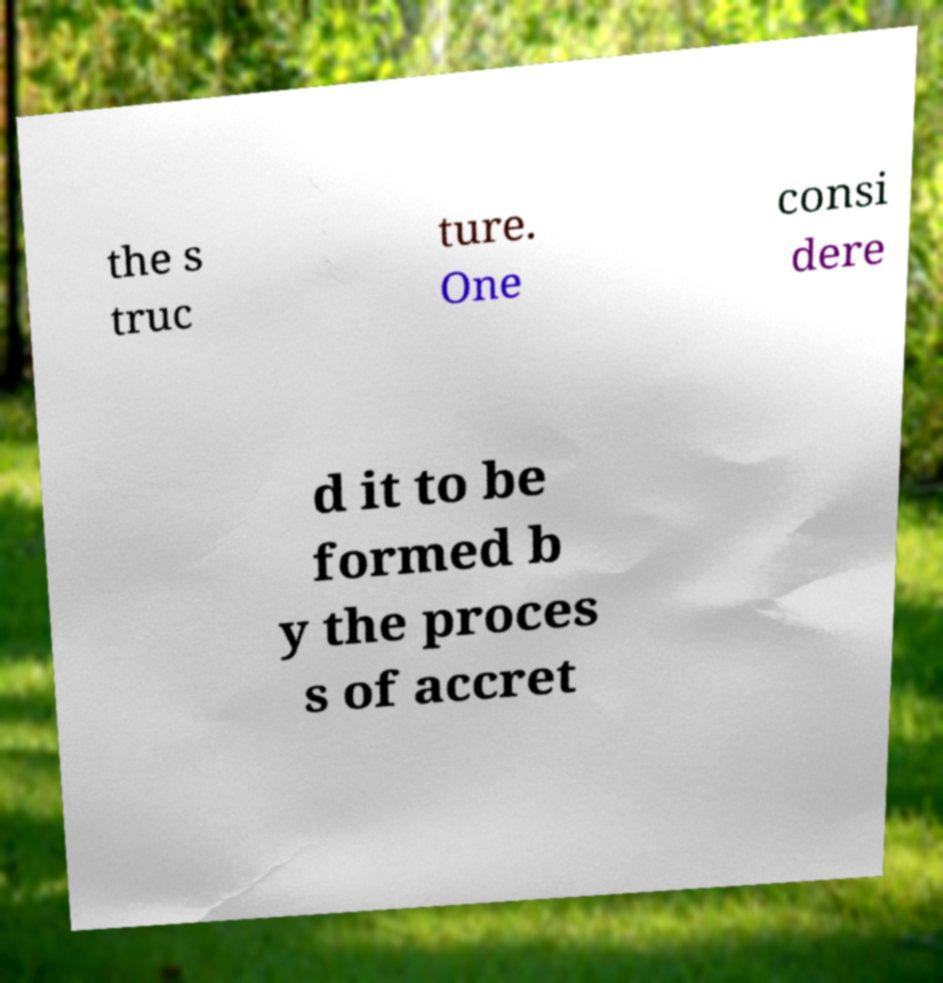Please identify and transcribe the text found in this image. the s truc ture. One consi dere d it to be formed b y the proces s of accret 